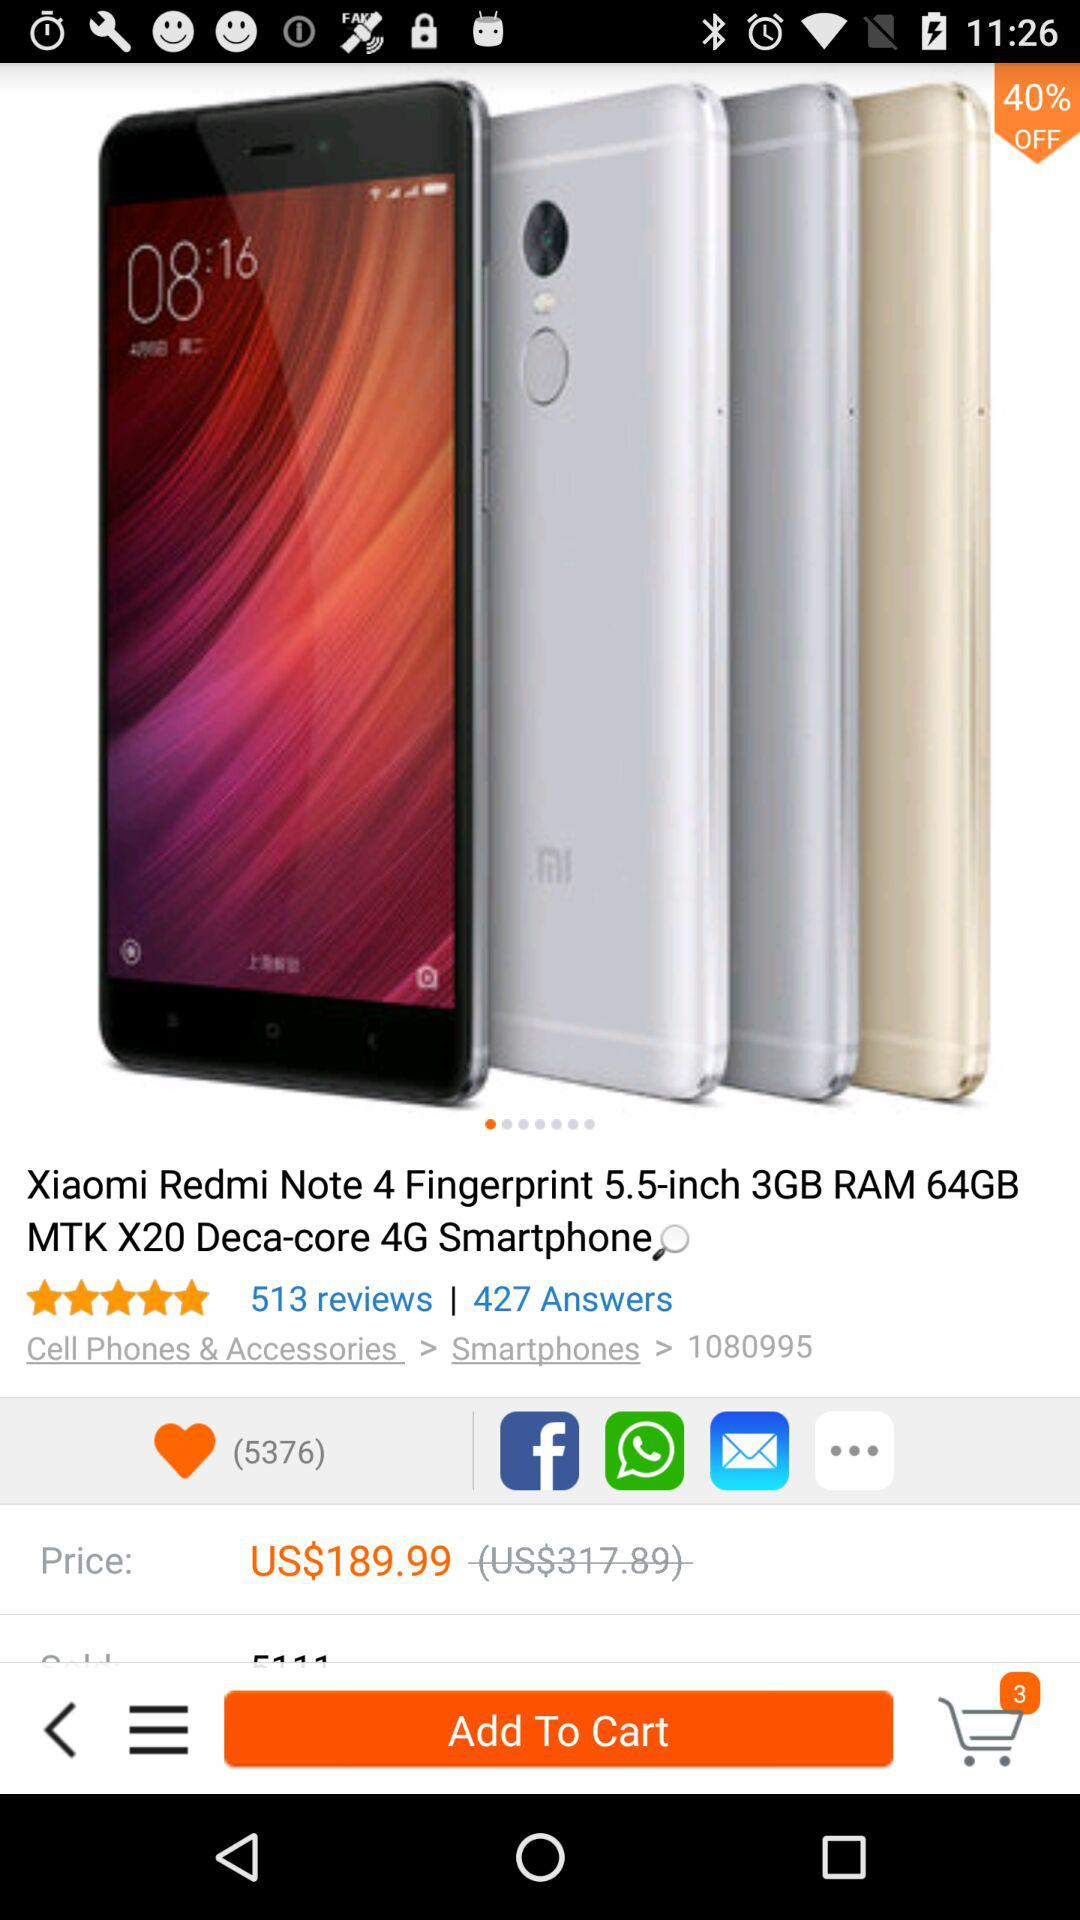What is the discount percentage on the "Xiaomi Redmi Note 4"? The discount percentage on the "Xiaomi Redmi Note 4" is 40. 